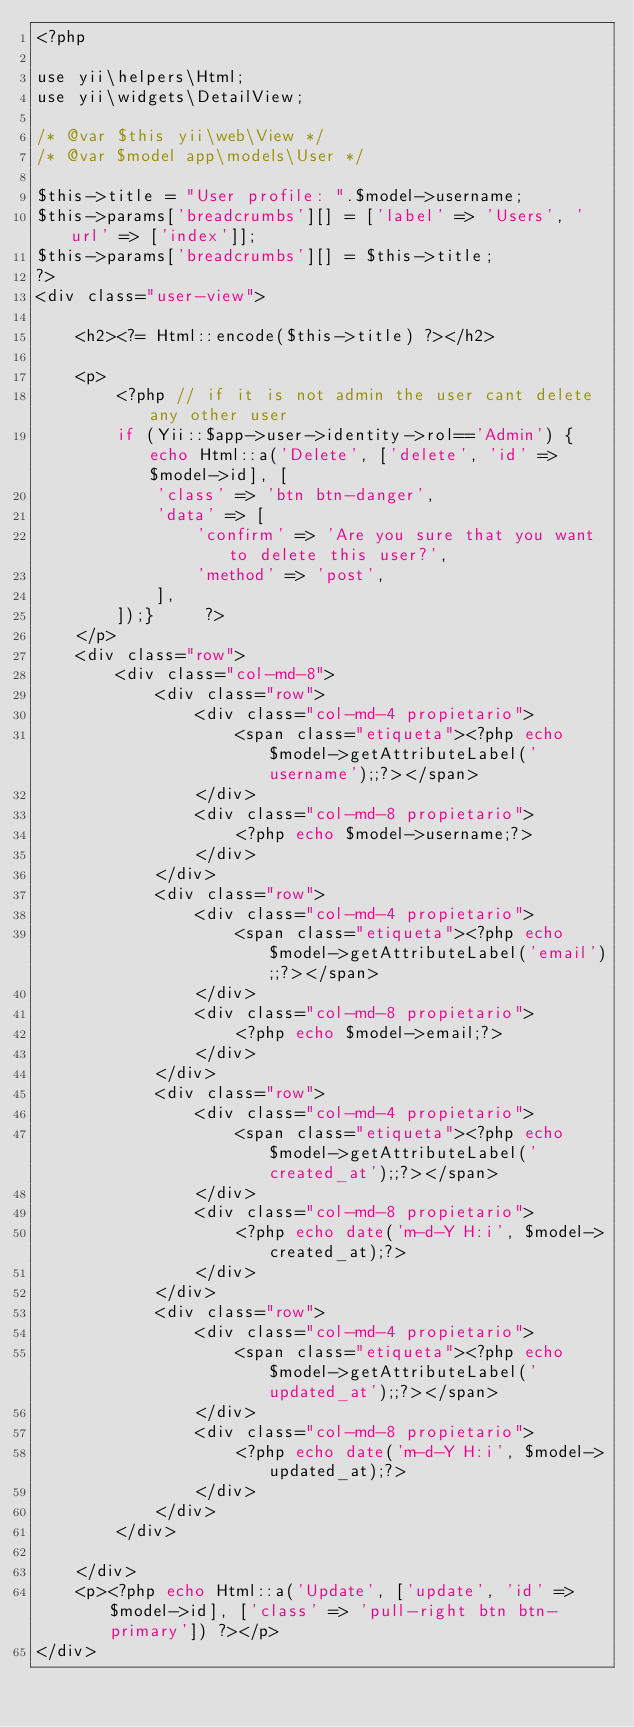<code> <loc_0><loc_0><loc_500><loc_500><_PHP_><?php

use yii\helpers\Html;
use yii\widgets\DetailView;

/* @var $this yii\web\View */
/* @var $model app\models\User */

$this->title = "User profile: ".$model->username;
$this->params['breadcrumbs'][] = ['label' => 'Users', 'url' => ['index']];
$this->params['breadcrumbs'][] = $this->title;
?>
<div class="user-view">

    <h2><?= Html::encode($this->title) ?></h2>

    <p>        
        <?php // if it is not admin the user cant delete any other user 
        if (Yii::$app->user->identity->rol=='Admin') {echo Html::a('Delete', ['delete', 'id' => $model->id], [
            'class' => 'btn btn-danger',
            'data' => [
                'confirm' => 'Are you sure that you want to delete this user?',
                'method' => 'post',
            ],
        ]);}     ?>
    </p>
	<div class="row">		
		<div class="col-md-8">
			<div class="row">
				<div class="col-md-4 propietario">
					<span class="etiqueta"><?php echo $model->getAttributeLabel('username');;?></span>
				</div>
				<div class="col-md-8 propietario">
					<?php echo $model->username;?>
				</div>
			</div>
			<div class="row">
				<div class="col-md-4 propietario">
					<span class="etiqueta"><?php echo $model->getAttributeLabel('email');;?></span>
				</div>
				<div class="col-md-8 propietario">
					<?php echo $model->email;?>
				</div>
			</div>
			<div class="row">
				<div class="col-md-4 propietario">
					<span class="etiqueta"><?php echo $model->getAttributeLabel('created_at');;?></span>
				</div>
				<div class="col-md-8 propietario">
					<?php echo date('m-d-Y H:i', $model->created_at);?>
				</div>
			</div>
			<div class="row">
				<div class="col-md-4 propietario">
					<span class="etiqueta"><?php echo $model->getAttributeLabel('updated_at');;?></span>
				</div>
				<div class="col-md-8 propietario">
					<?php echo date('m-d-Y H:i', $model->updated_at);?>
				</div>
			</div>
		</div>
		
	</div>
	<p><?php echo Html::a('Update', ['update', 'id' => $model->id], ['class' => 'pull-right btn btn-primary']) ?></p>
</div></code> 